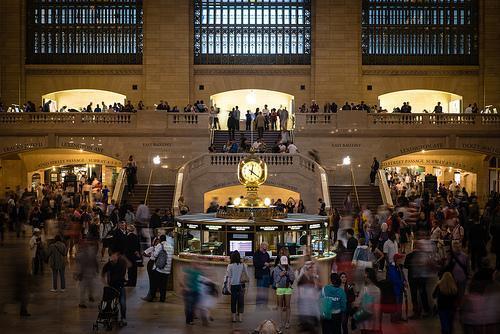How many staircases are visible?
Give a very brief answer. 3. 